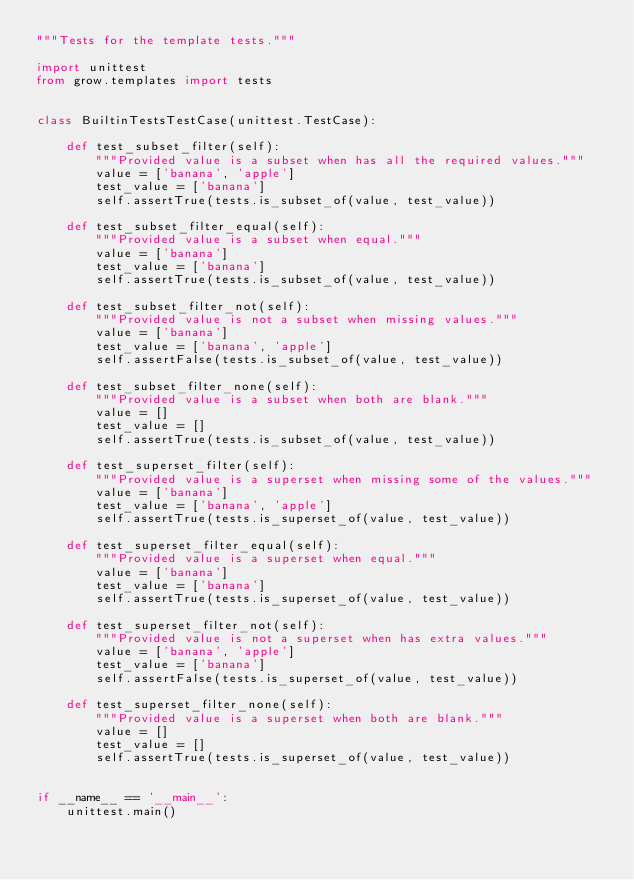Convert code to text. <code><loc_0><loc_0><loc_500><loc_500><_Python_>"""Tests for the template tests."""

import unittest
from grow.templates import tests


class BuiltinTestsTestCase(unittest.TestCase):

    def test_subset_filter(self):
        """Provided value is a subset when has all the required values."""
        value = ['banana', 'apple']
        test_value = ['banana']
        self.assertTrue(tests.is_subset_of(value, test_value))

    def test_subset_filter_equal(self):
        """Provided value is a subset when equal."""
        value = ['banana']
        test_value = ['banana']
        self.assertTrue(tests.is_subset_of(value, test_value))

    def test_subset_filter_not(self):
        """Provided value is not a subset when missing values."""
        value = ['banana']
        test_value = ['banana', 'apple']
        self.assertFalse(tests.is_subset_of(value, test_value))

    def test_subset_filter_none(self):
        """Provided value is a subset when both are blank."""
        value = []
        test_value = []
        self.assertTrue(tests.is_subset_of(value, test_value))

    def test_superset_filter(self):
        """Provided value is a superset when missing some of the values."""
        value = ['banana']
        test_value = ['banana', 'apple']
        self.assertTrue(tests.is_superset_of(value, test_value))

    def test_superset_filter_equal(self):
        """Provided value is a superset when equal."""
        value = ['banana']
        test_value = ['banana']
        self.assertTrue(tests.is_superset_of(value, test_value))

    def test_superset_filter_not(self):
        """Provided value is not a superset when has extra values."""
        value = ['banana', 'apple']
        test_value = ['banana']
        self.assertFalse(tests.is_superset_of(value, test_value))

    def test_superset_filter_none(self):
        """Provided value is a superset when both are blank."""
        value = []
        test_value = []
        self.assertTrue(tests.is_superset_of(value, test_value))


if __name__ == '__main__':
    unittest.main()
</code> 